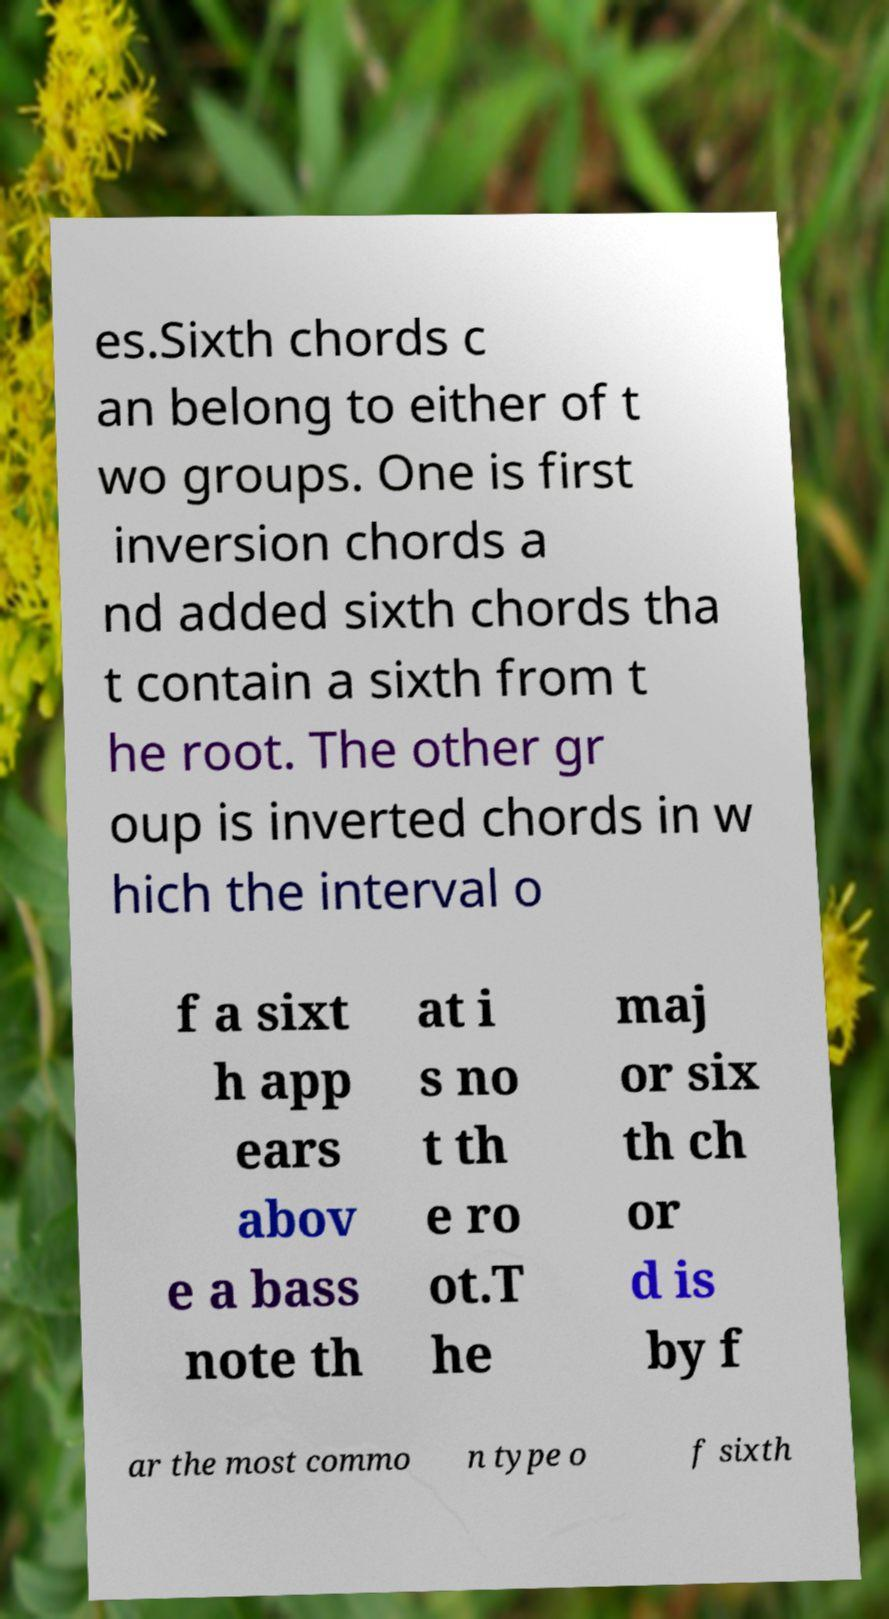There's text embedded in this image that I need extracted. Can you transcribe it verbatim? es.Sixth chords c an belong to either of t wo groups. One is first inversion chords a nd added sixth chords tha t contain a sixth from t he root. The other gr oup is inverted chords in w hich the interval o f a sixt h app ears abov e a bass note th at i s no t th e ro ot.T he maj or six th ch or d is by f ar the most commo n type o f sixth 